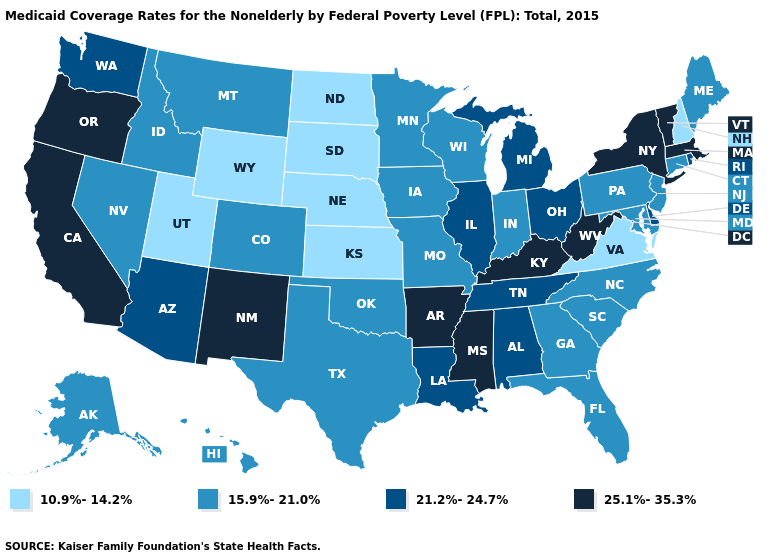Does Ohio have the same value as New Hampshire?
Give a very brief answer. No. Does Maryland have the highest value in the South?
Short answer required. No. Does the first symbol in the legend represent the smallest category?
Short answer required. Yes. Does the first symbol in the legend represent the smallest category?
Write a very short answer. Yes. What is the value of California?
Keep it brief. 25.1%-35.3%. Name the states that have a value in the range 21.2%-24.7%?
Give a very brief answer. Alabama, Arizona, Delaware, Illinois, Louisiana, Michigan, Ohio, Rhode Island, Tennessee, Washington. Does Illinois have a lower value than New Mexico?
Quick response, please. Yes. Does Arkansas have the same value as New York?
Give a very brief answer. Yes. What is the lowest value in the USA?
Write a very short answer. 10.9%-14.2%. What is the lowest value in states that border Maine?
Write a very short answer. 10.9%-14.2%. Does Oregon have the highest value in the USA?
Short answer required. Yes. Name the states that have a value in the range 21.2%-24.7%?
Concise answer only. Alabama, Arizona, Delaware, Illinois, Louisiana, Michigan, Ohio, Rhode Island, Tennessee, Washington. Among the states that border Montana , which have the lowest value?
Quick response, please. North Dakota, South Dakota, Wyoming. Among the states that border North Carolina , does Tennessee have the highest value?
Quick response, please. Yes. Does Illinois have a lower value than New Hampshire?
Be succinct. No. 